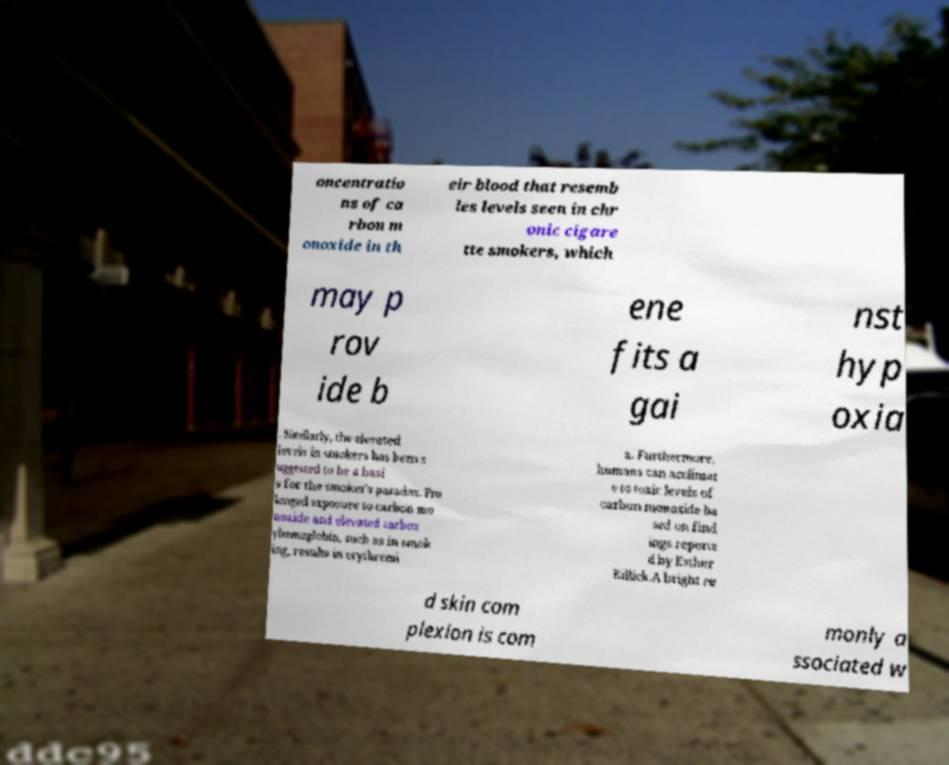Can you read and provide the text displayed in the image?This photo seems to have some interesting text. Can you extract and type it out for me? oncentratio ns of ca rbon m onoxide in th eir blood that resemb les levels seen in chr onic cigare tte smokers, which may p rov ide b ene fits a gai nst hyp oxia . Similarly, the elevated levels in smokers has been s uggested to be a basi s for the smoker's paradox. Pro longed exposure to carbon mo noxide and elevated carbox yhemoglobin, such as in smok ing, results in erythremi a. Furthermore, humans can acclimat e to toxic levels of carbon monoxide ba sed on find ings reporte d by Esther Killick.A bright re d skin com plexion is com monly a ssociated w 